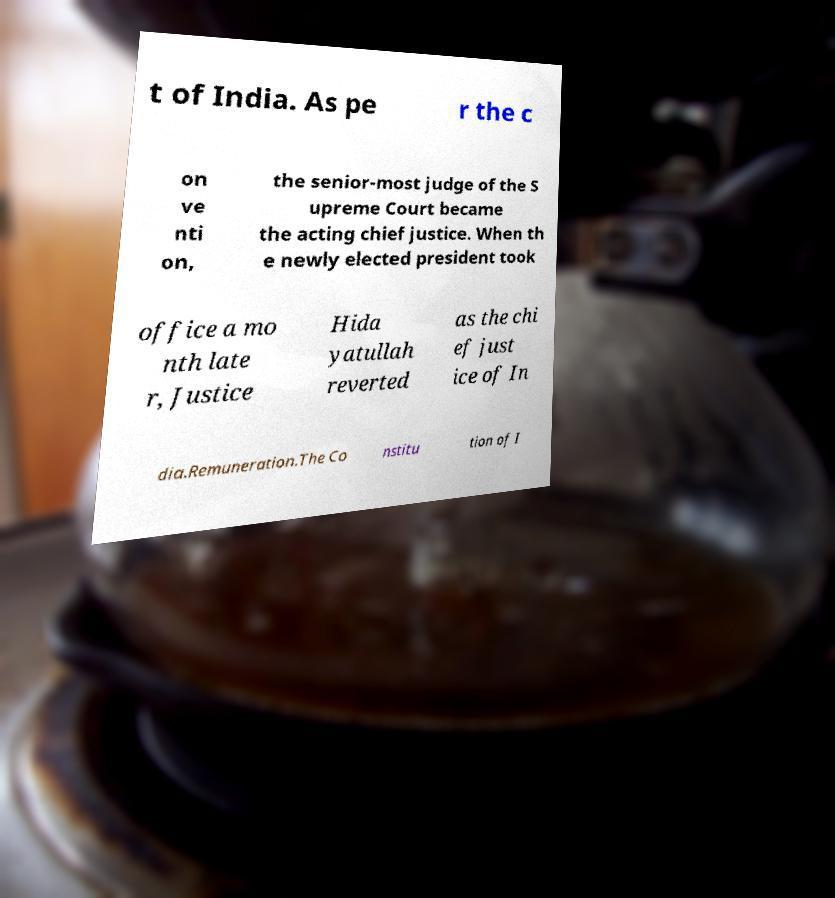Can you accurately transcribe the text from the provided image for me? t of India. As pe r the c on ve nti on, the senior-most judge of the S upreme Court became the acting chief justice. When th e newly elected president took office a mo nth late r, Justice Hida yatullah reverted as the chi ef just ice of In dia.Remuneration.The Co nstitu tion of I 